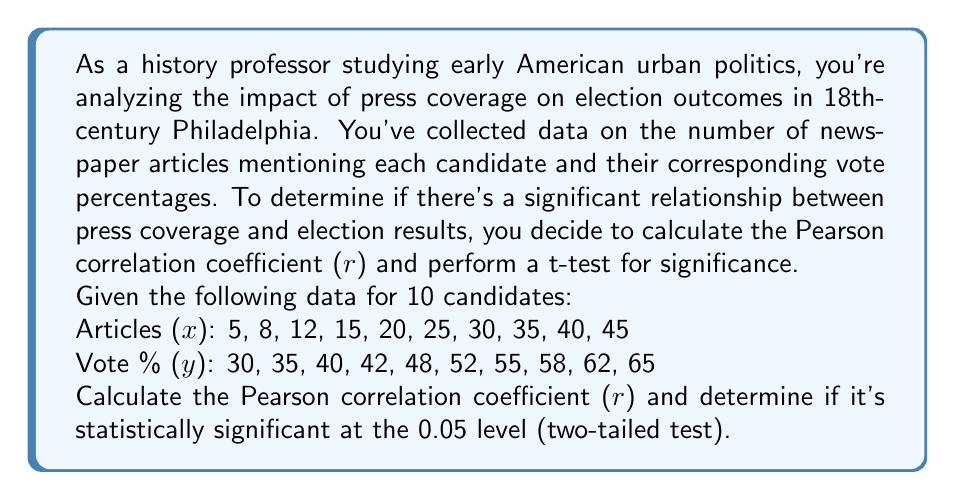Could you help me with this problem? To solve this problem, we'll follow these steps:

1. Calculate the Pearson correlation coefficient (r)
2. Perform a t-test to determine statistical significance

Step 1: Calculate the Pearson correlation coefficient (r)

The formula for r is:

$$ r = \frac{n\sum xy - (\sum x)(\sum y)}{\sqrt{[n\sum x^2 - (\sum x)^2][n\sum y^2 - (\sum y)^2]}} $$

First, let's calculate the necessary sums:

$\sum x = 235$
$\sum y = 487$
$\sum xy = 13,475$
$\sum x^2 = 7,275$
$\sum y^2 = 24,763$
$n = 10$

Now, let's plug these values into the formula:

$$ r = \frac{10(13,475) - (235)(487)}{\sqrt{[10(7,275) - 235^2][10(24,763) - 487^2]}} $$

$$ r = \frac{134,750 - 114,445}{\sqrt{(72,750 - 55,225)(247,630 - 237,169)}} $$

$$ r = \frac{20,305}{\sqrt{(17,525)(10,461)}} = \frac{20,305}{\sqrt{183,327,525}} = \frac{20,305}{13,539.41} $$

$$ r \approx 0.9999 $$

Step 2: Perform a t-test to determine statistical significance

The formula for the t-statistic is:

$$ t = \frac{r\sqrt{n-2}}{\sqrt{1-r^2}} $$

Plugging in our values:

$$ t = \frac{0.9999\sqrt{10-2}}{\sqrt{1-0.9999^2}} = \frac{0.9999\sqrt{8}}{\sqrt{1-0.9998}} $$

$$ t = \frac{0.9999(2.8284)}{\sqrt{0.0002}} = \frac{2.8281}{0.0141} $$

$$ t \approx 200.5745 $$

The degrees of freedom (df) for this test is n - 2 = 8.

For a two-tailed test at the 0.05 significance level with 8 df, the critical t-value is approximately ±2.306.

Since our calculated t-value (200.5745) is much larger than the critical value, we can conclude that the correlation is statistically significant at the 0.05 level.
Answer: r ≈ 0.9999, statistically significant (p < 0.05) 